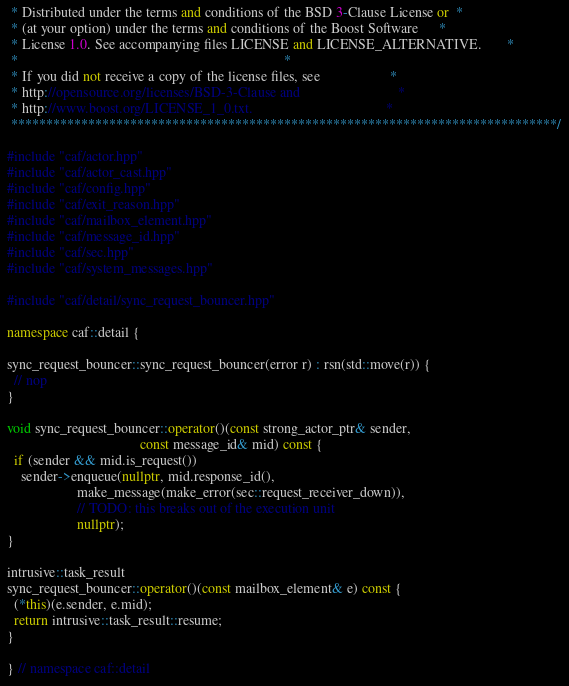Convert code to text. <code><loc_0><loc_0><loc_500><loc_500><_C++_> * Distributed under the terms and conditions of the BSD 3-Clause License or  *
 * (at your option) under the terms and conditions of the Boost Software      *
 * License 1.0. See accompanying files LICENSE and LICENSE_ALTERNATIVE.       *
 *                                                                            *
 * If you did not receive a copy of the license files, see                    *
 * http://opensource.org/licenses/BSD-3-Clause and                            *
 * http://www.boost.org/LICENSE_1_0.txt.                                      *
 ******************************************************************************/

#include "caf/actor.hpp"
#include "caf/actor_cast.hpp"
#include "caf/config.hpp"
#include "caf/exit_reason.hpp"
#include "caf/mailbox_element.hpp"
#include "caf/message_id.hpp"
#include "caf/sec.hpp"
#include "caf/system_messages.hpp"

#include "caf/detail/sync_request_bouncer.hpp"

namespace caf::detail {

sync_request_bouncer::sync_request_bouncer(error r) : rsn(std::move(r)) {
  // nop
}

void sync_request_bouncer::operator()(const strong_actor_ptr& sender,
                                      const message_id& mid) const {
  if (sender && mid.is_request())
    sender->enqueue(nullptr, mid.response_id(),
                    make_message(make_error(sec::request_receiver_down)),
                    // TODO: this breaks out of the execution unit
                    nullptr);
}

intrusive::task_result
sync_request_bouncer::operator()(const mailbox_element& e) const {
  (*this)(e.sender, e.mid);
  return intrusive::task_result::resume;
}

} // namespace caf::detail
</code> 